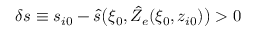<formula> <loc_0><loc_0><loc_500><loc_500>\delta s \equiv s _ { i 0 } - \hat { s } \left ( \xi _ { 0 } , \hat { Z } _ { e } ( \xi _ { 0 } , z _ { i 0 } ) \right ) > 0</formula> 